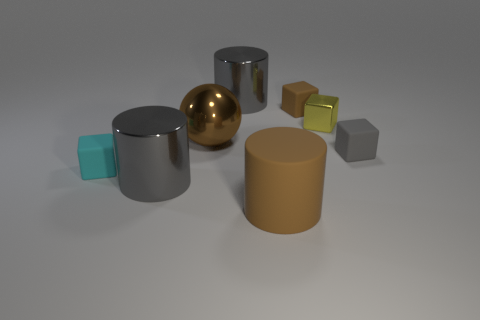There is a cylinder that is the same color as the sphere; what size is it?
Your answer should be very brief. Large. Do the shiny ball that is in front of the tiny shiny cube and the large rubber thing have the same color?
Provide a succinct answer. Yes. Is the color of the rubber cylinder the same as the large sphere?
Ensure brevity in your answer.  Yes. Are there any other things that have the same shape as the large brown shiny object?
Keep it short and to the point. No. What material is the tiny block that is the same color as the large sphere?
Offer a terse response. Rubber. Are there any small gray matte objects to the left of the small yellow metallic block?
Ensure brevity in your answer.  No. Do the yellow metallic thing and the big gray metallic thing behind the brown cube have the same shape?
Your answer should be very brief. No. There is another big thing that is the same material as the cyan object; what color is it?
Give a very brief answer. Brown. What is the color of the large sphere?
Provide a short and direct response. Brown. Is the material of the tiny brown cube the same as the small object right of the small yellow shiny cube?
Your response must be concise. Yes. 